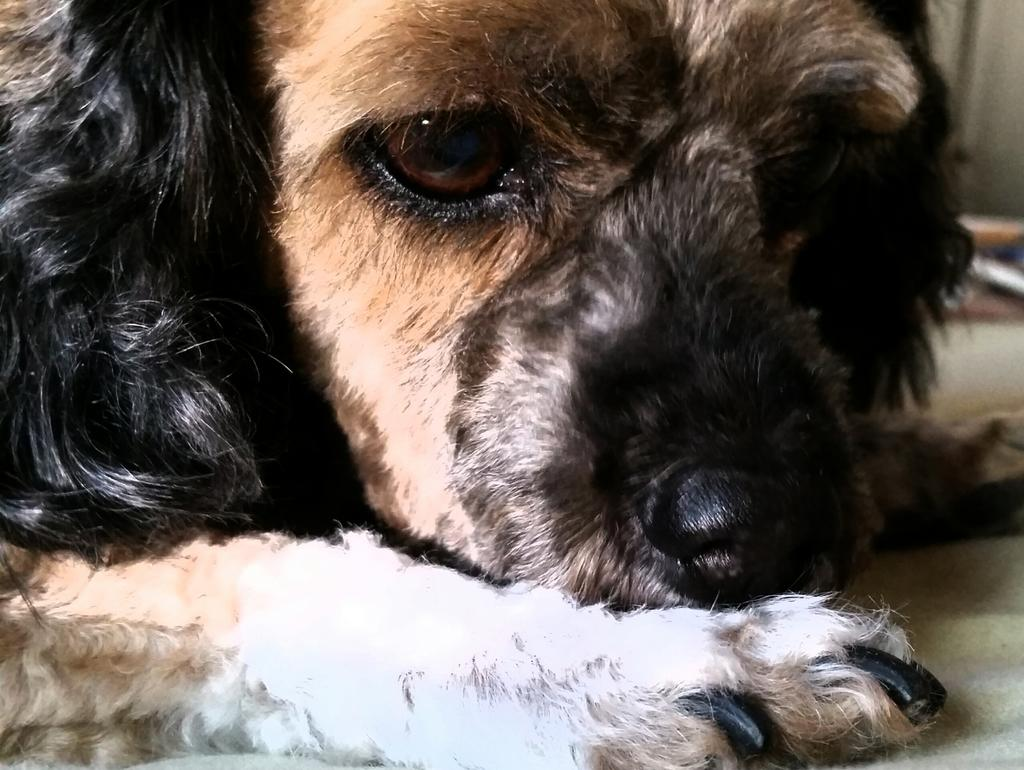What type of animal is in the image? There is a dog in the image. What can be seen beneath the dog? The ground is visible in the image. What type of fruit is the dog holding in the image? There is no fruit present in the image, and the dog is not holding anything. 